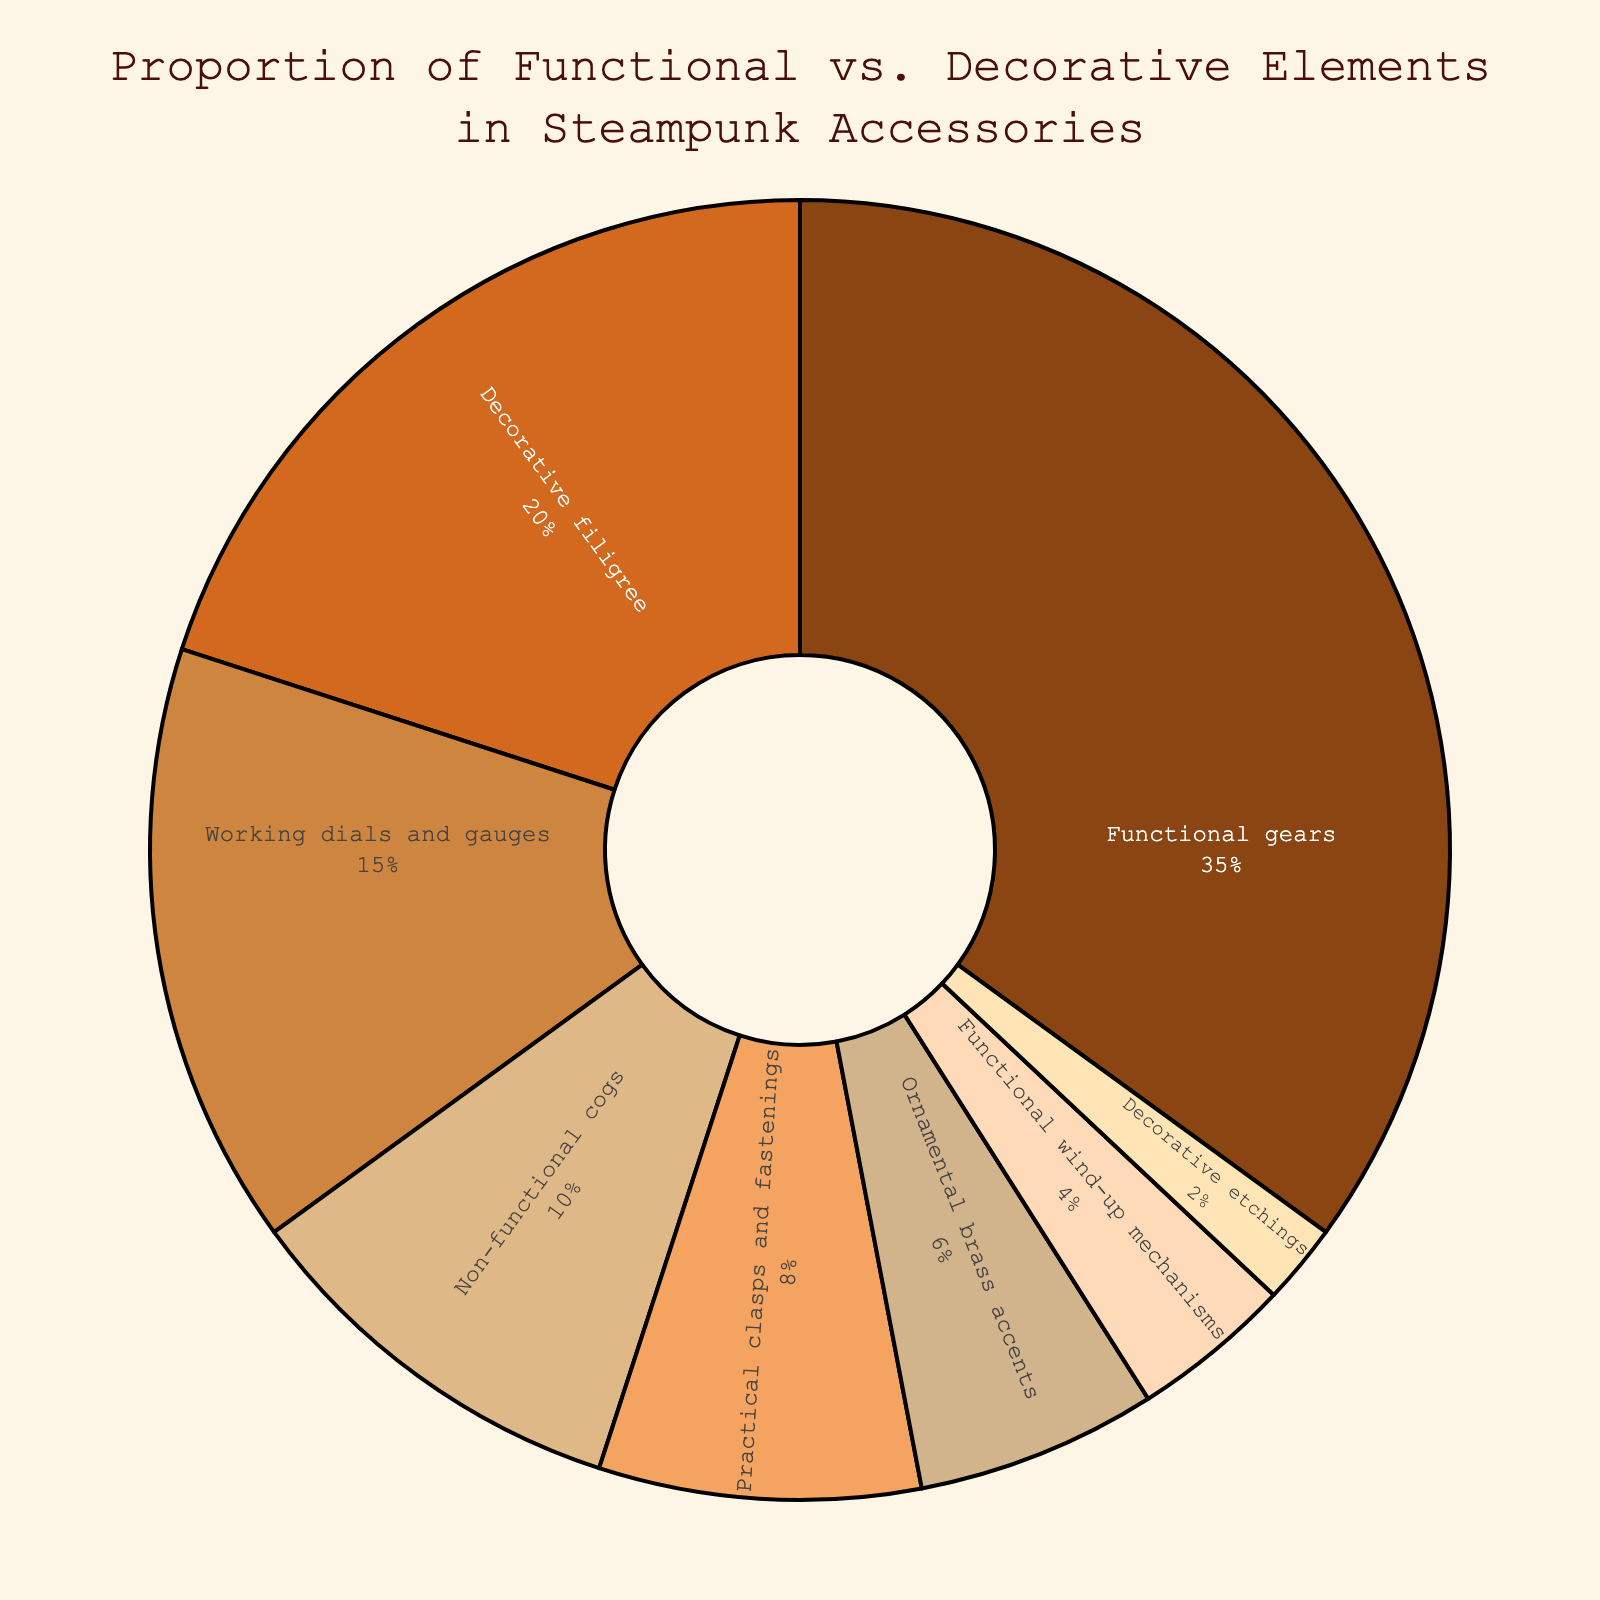Which element has the largest proportion in the steampunk accessories? The element with the largest proportion can be identified by looking for the largest segment in the pie chart. The largest proportion belongs to "Functional gears," which occupies 35% of the chart.
Answer: Functional gears What is the combined percentage of all functional elements? Adding the percentages of all elements labeled as functional: Functional gears (35%) + Working dials and gauges (15%) + Practical clasps and fastenings (8%) + Functional wind-up mechanisms (4%). Summing these gives 35 + 15 + 8 + 4 = 62%.
Answer: 62% Which decorative element has the smallest proportion? To find the smallest decorative element, we need to identify the smallest segment among decorative elements, which is "Decorative etchings" with 2%.
Answer: Decorative etchings Compare the proportion of "Functional gears" and "Decorative filigree." Which is larger and by how much? The proportion of "Functional gears" is 35%, and "Decorative filigree" is 20%. Subtracting 20 from 35 gives 15 percentage points. Therefore, "Functional gears" is larger by 15%.
Answer: Functional gears, 15% What is the difference in proportion between "Non-functional cogs" and "Practical clasps and fastenings"? "Non-functional cogs" has a proportion of 10%, and "Practical clasps and fastenings" has 8%. The difference is 10 - 8 = 2%.
Answer: 2% Which two elements combined make up approximately one-third of the chart? One-third of the chart is approximately 33%. The two elements that sum up close to this value are "Functional gears" (35%) and "Decorative filigree" (20%). However, 35% alone already exceeds one-third. Instead, "Working dials and gauges" (15%) and "Non-functional cogs" (10%) make up 15 + 10 = 25%, which is less than one-third, while including "Practical clasps and fastenings" (8%) gives 23%. For approximate accuracy, "Functional gears" alone is a close approximation to one-third.
Answer: Functional gears How many elements have a proportion greater than 10%? By counting segments with more than 10%: "Functional gears" (35%), "Decorative filigree" (20%), and "Working dials and gauges" (15%) are the only segments above 10%. There are 3 elements.
Answer: 3 Is the combined proportion of "Ornamental brass accents" and "Decorative etchings" more or less than "Functional wind-up mechanisms"? Adding the proportions of "Ornamental brass accents" (6%) and "Decorative etchings" (2%) gives 6 + 2 = 8%. "Functional wind-up mechanisms" has 4%. Therefore, the combined proportion is more.
Answer: More What is the average proportion of decorative elements? Sum the percentages of decorative elements: Decorative filigree (20%) + Non-functional cogs (10%) + Ornamental brass accents (6%) + Decorative etchings (2%) = 20 + 10 + 6 + 2 = 38%. There are 4 decorative elements, so the average is 38 / 4 = 9.5%.
Answer: 9.5% 